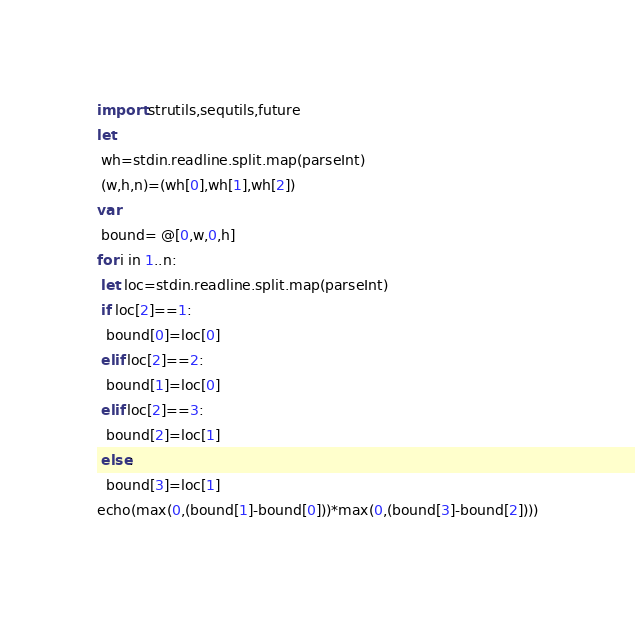<code> <loc_0><loc_0><loc_500><loc_500><_Nim_>import strutils,sequtils,future
let
 wh=stdin.readline.split.map(parseInt)
 (w,h,n)=(wh[0],wh[1],wh[2])
var
 bound= @[0,w,0,h]
for i in 1..n:
 let loc=stdin.readline.split.map(parseInt)
 if loc[2]==1:
  bound[0]=loc[0]
 elif loc[2]==2:
  bound[1]=loc[0]
 elif loc[2]==3:
  bound[2]=loc[1]
 else:
  bound[3]=loc[1]
echo(max(0,(bound[1]-bound[0]))*max(0,(bound[3]-bound[2])))</code> 